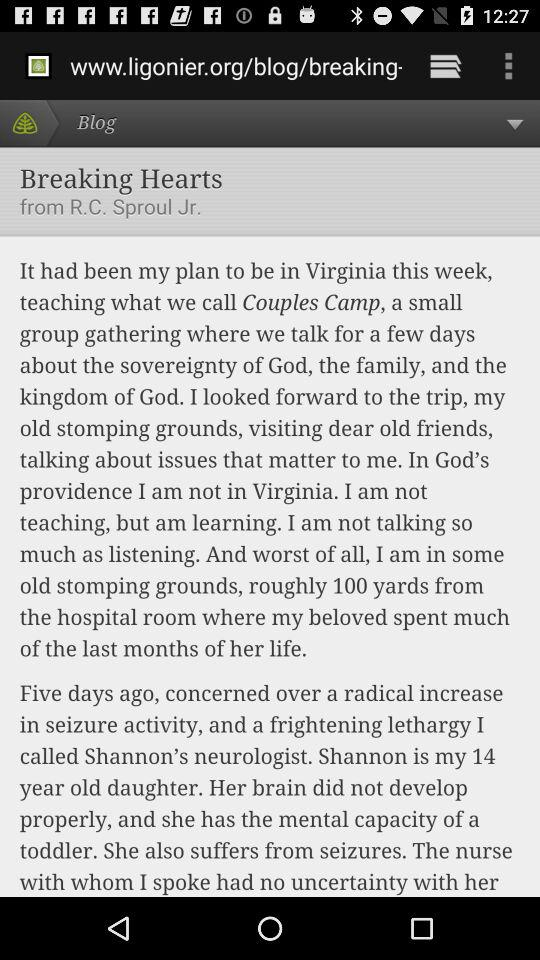Who has written the blog "Breaking Hearts"? The blog is written by "R.C. Sproul Jr.". 